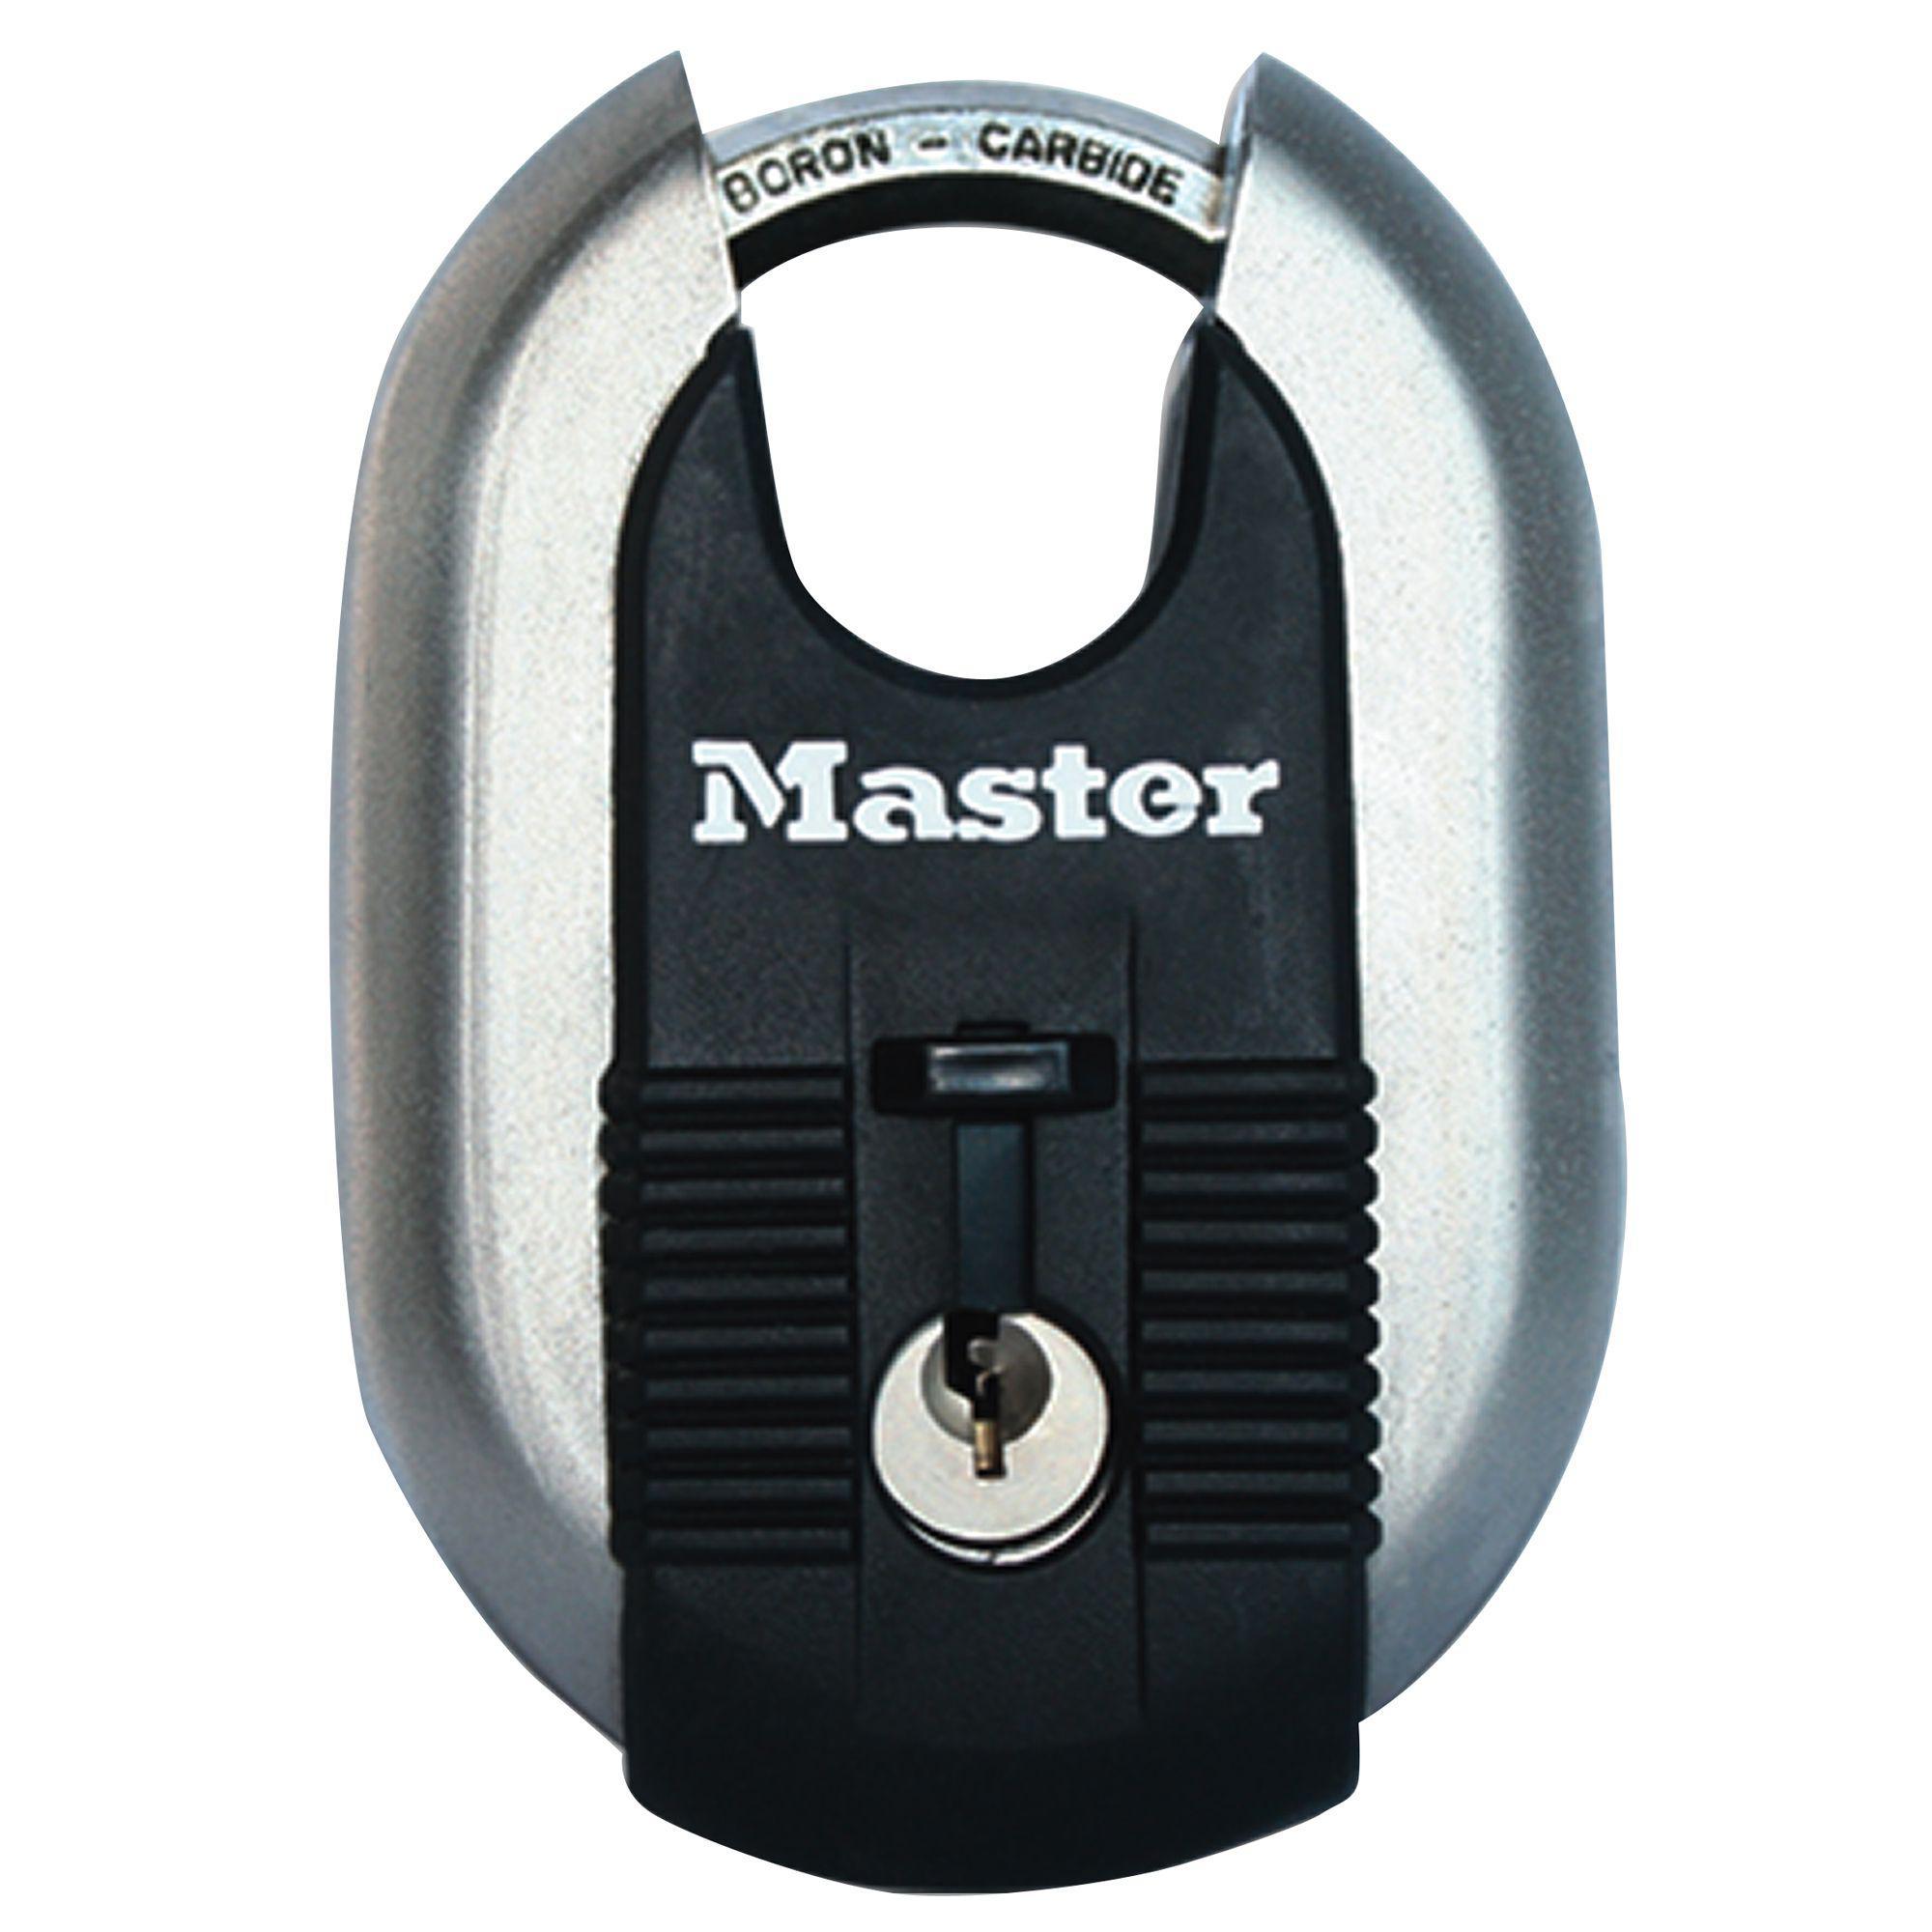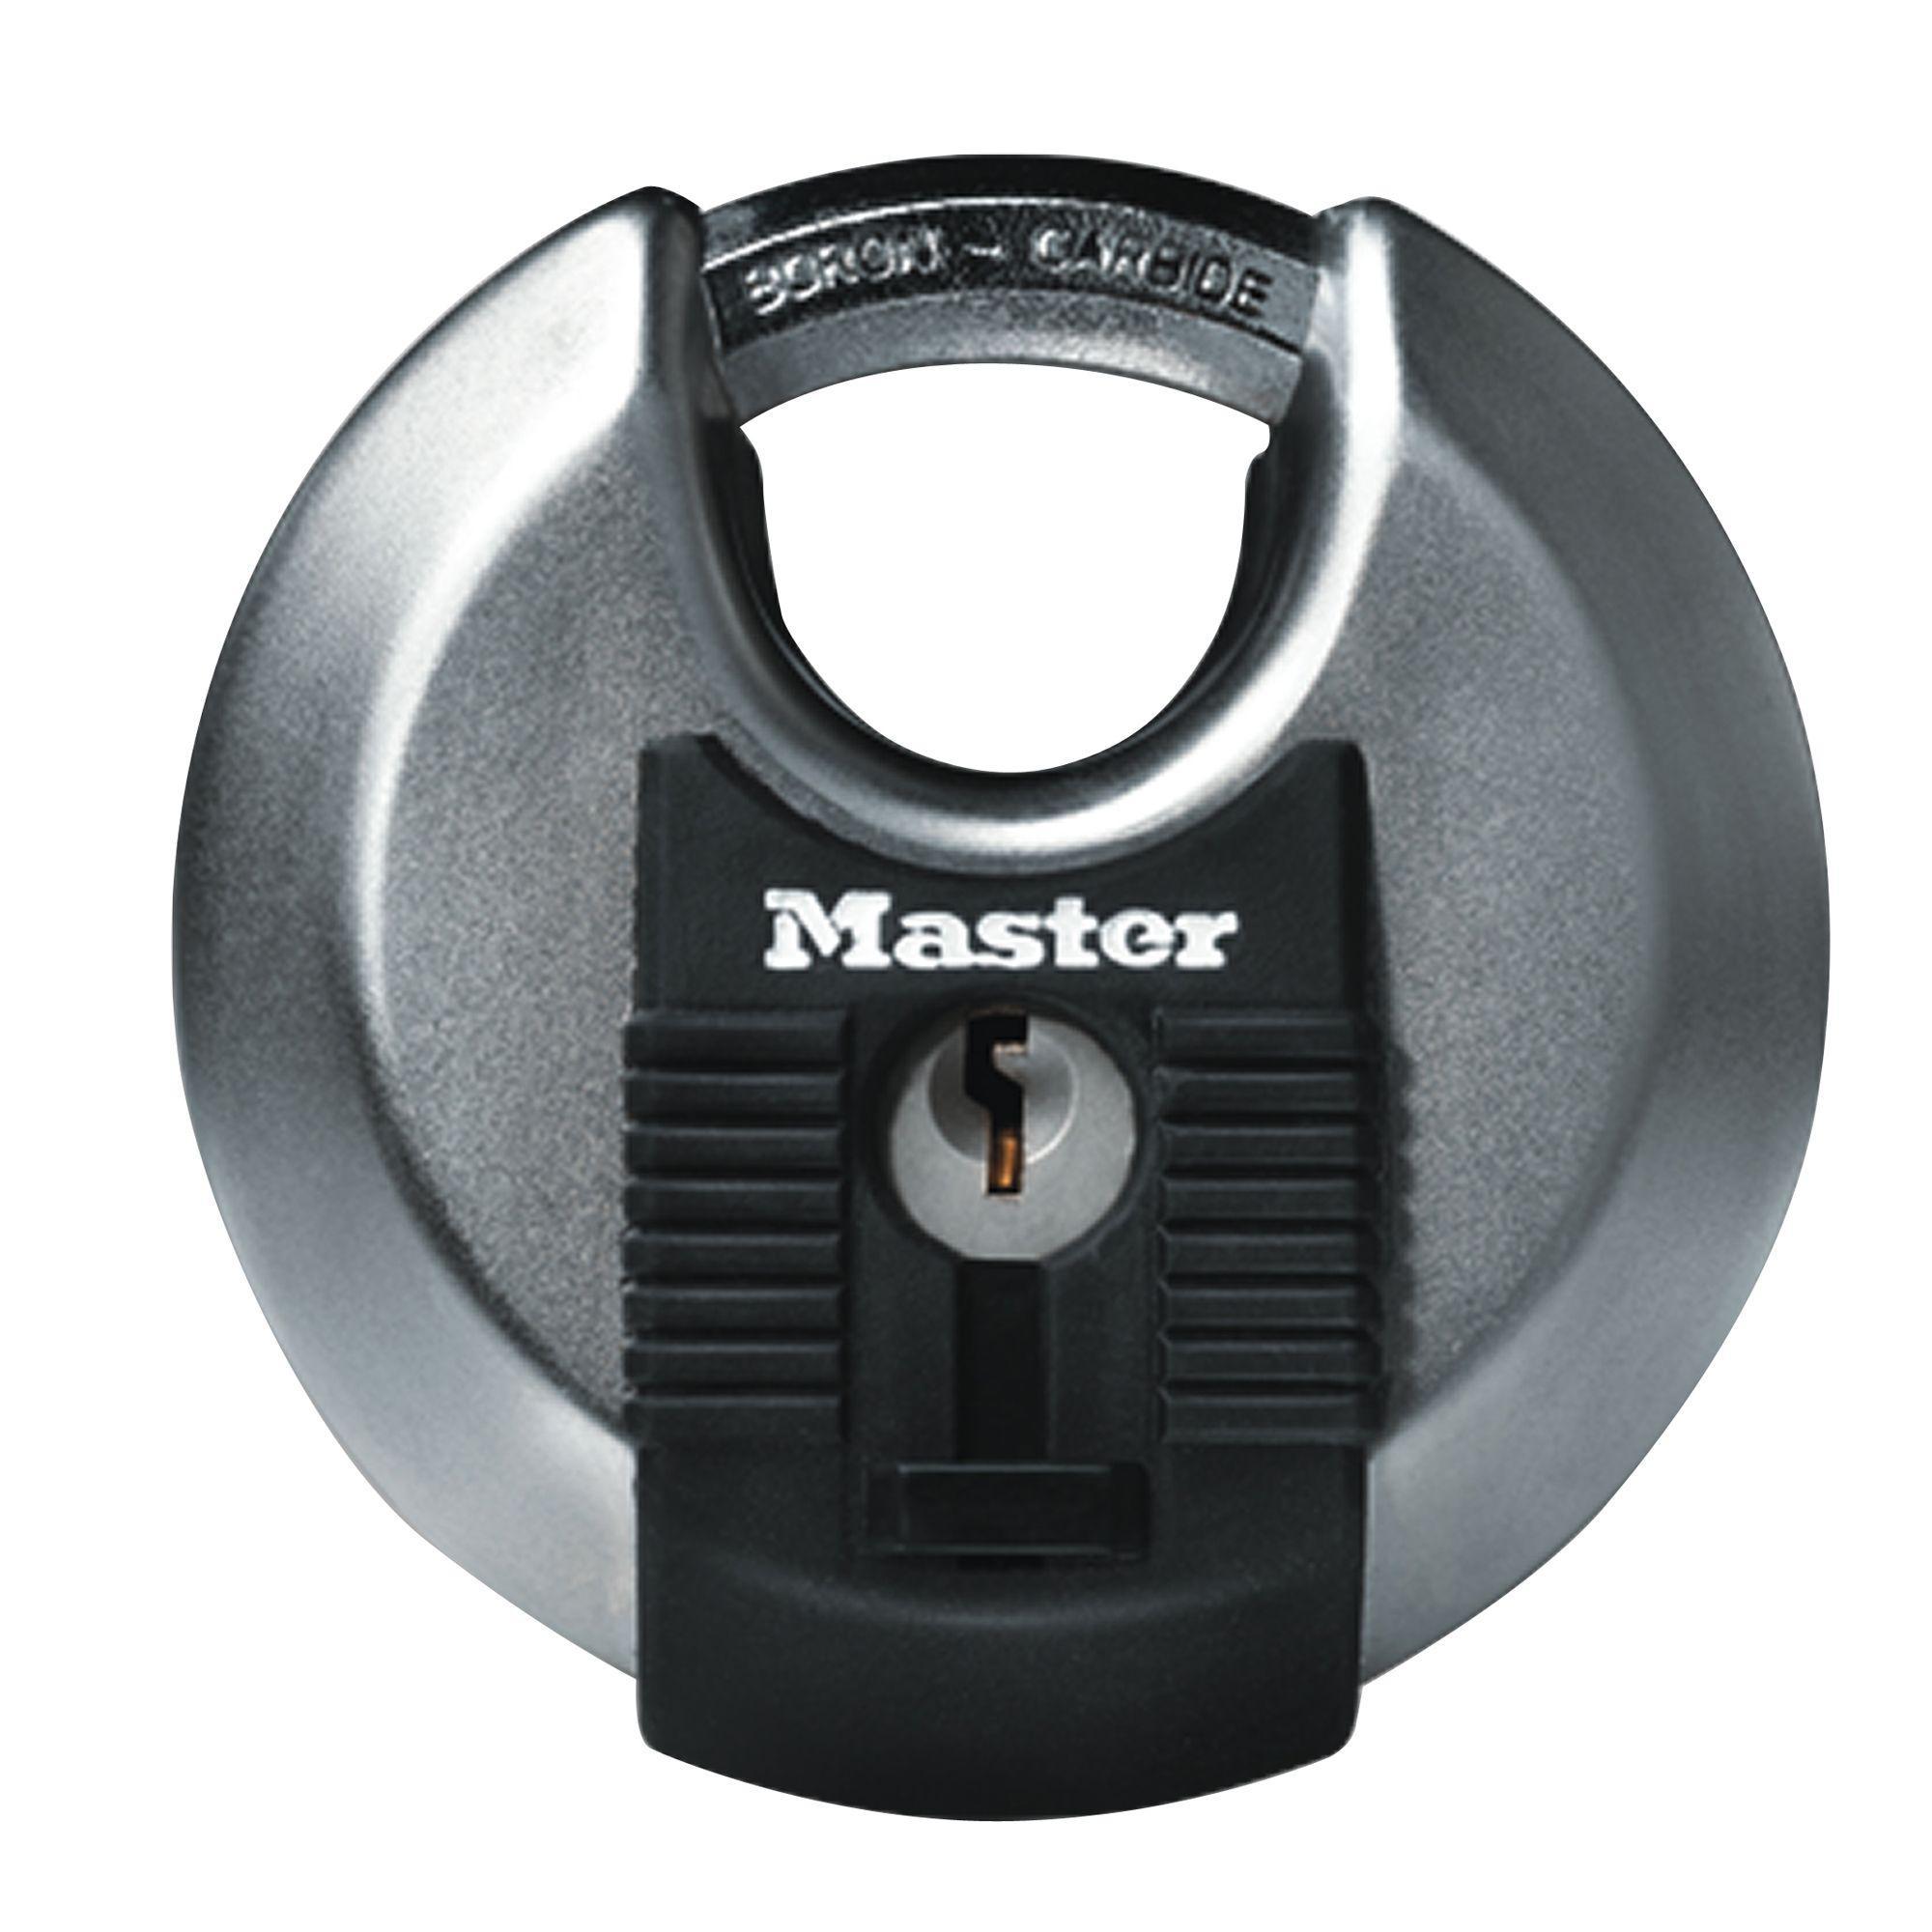The first image is the image on the left, the second image is the image on the right. Analyze the images presented: Is the assertion "Each image shows one non-square lock, and neither lock has wheels with a combination on the front." valid? Answer yes or no. Yes. The first image is the image on the left, the second image is the image on the right. Assess this claim about the two images: "All of the locks require keys.". Correct or not? Answer yes or no. Yes. 